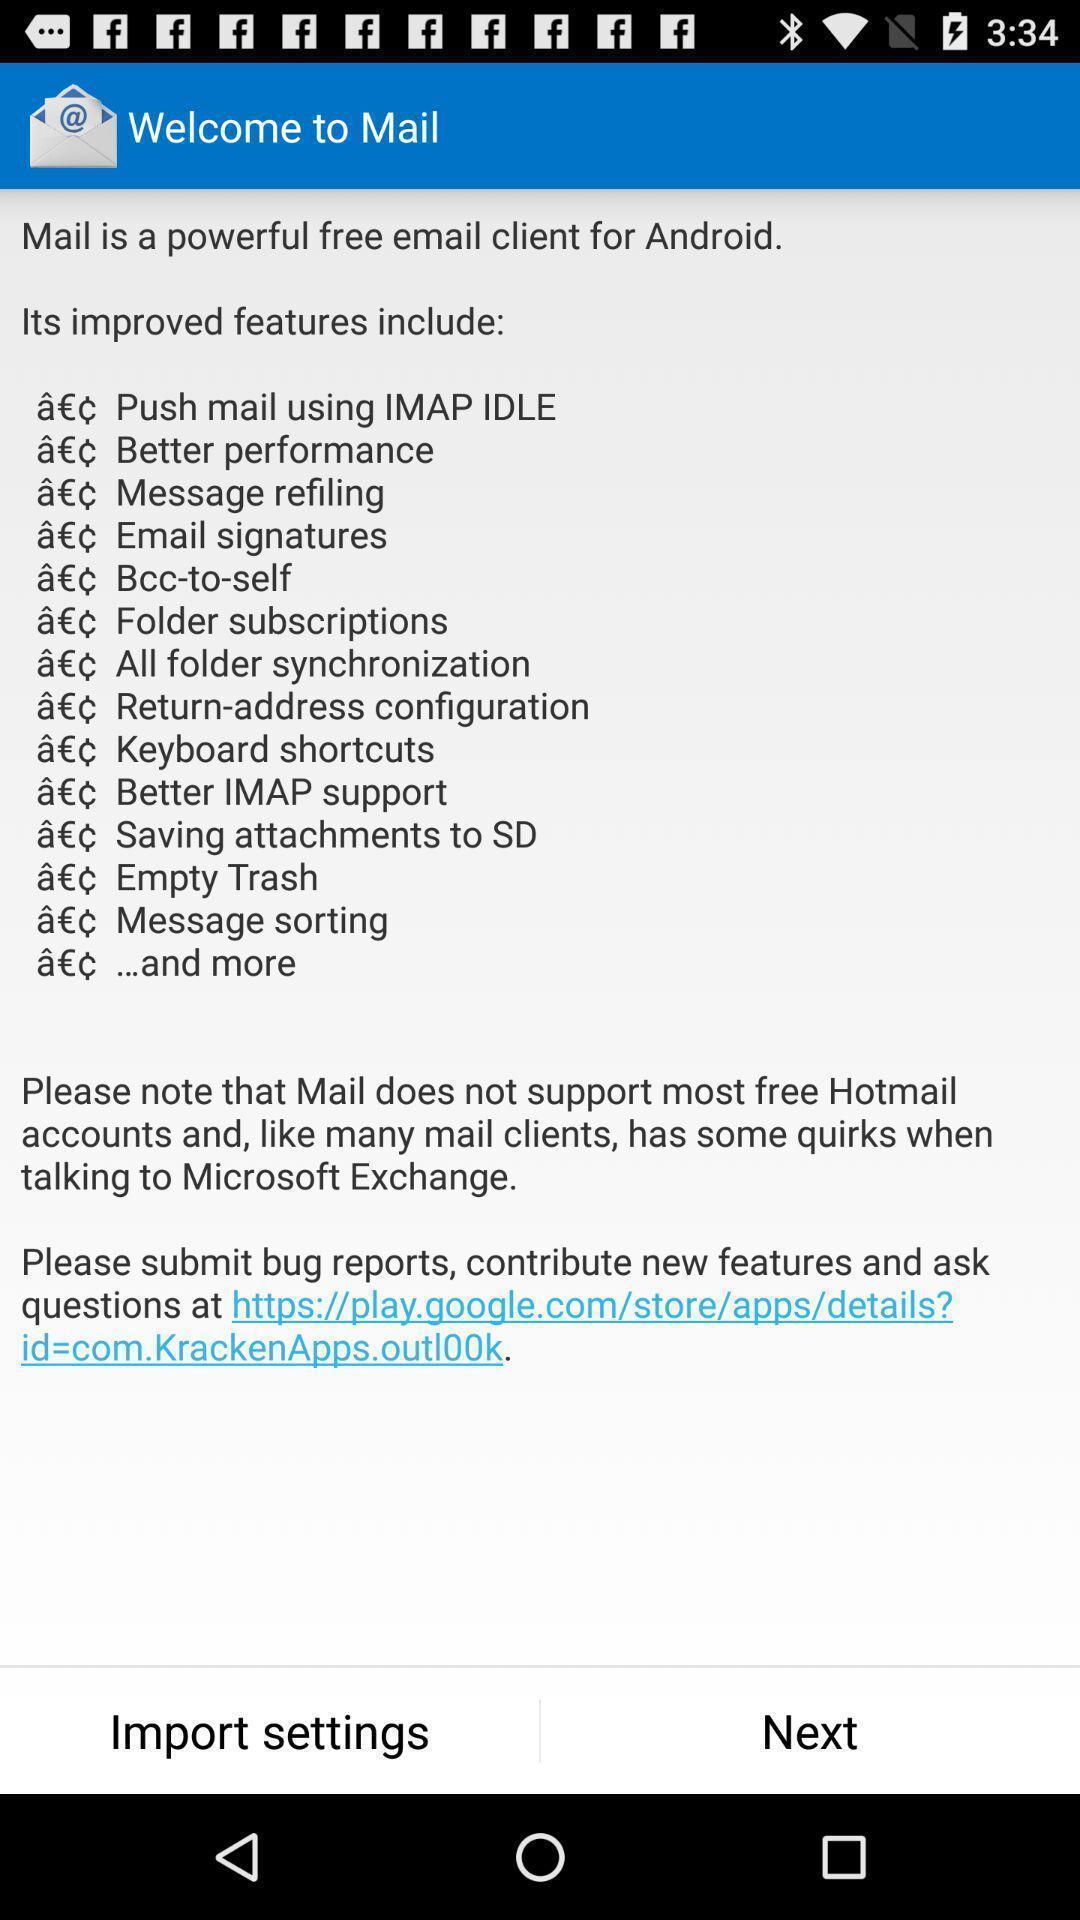Give me a narrative description of this picture. Welcome page. 